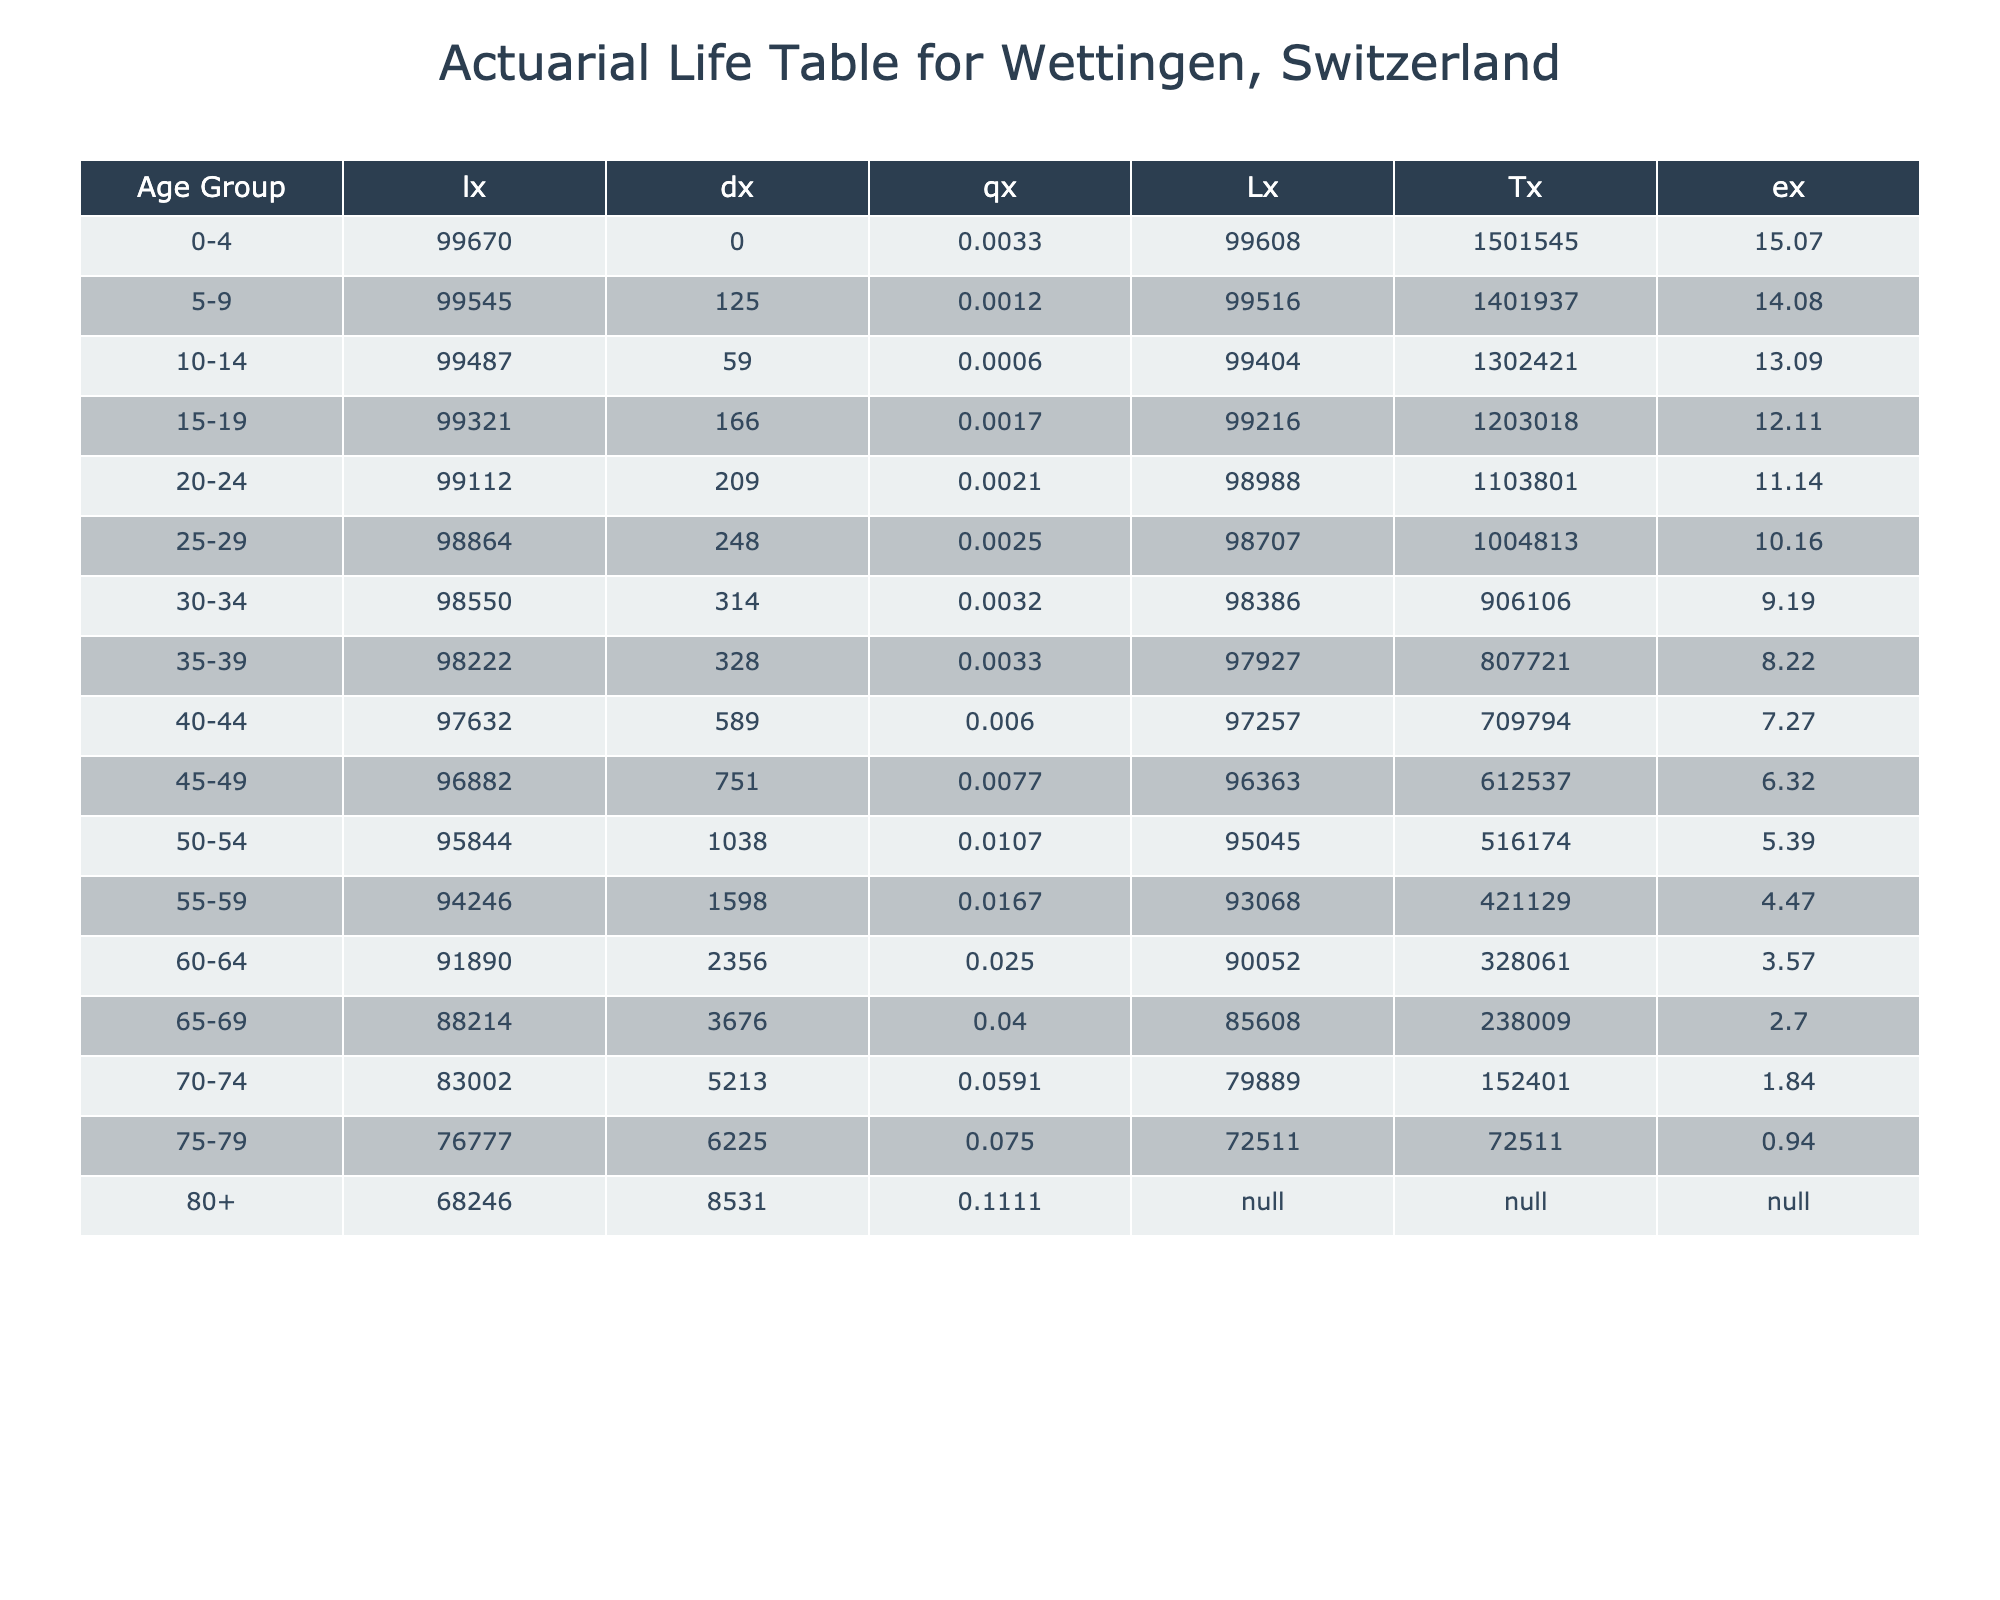What is the mortality rate for the age group 70-74? Looking at the table, we can find the row corresponding to the age group 70-74. The mortality rate in that row is listed as 0.05909.
Answer: 0.05909 How many deaths occurred in the age group 60-64? In the table, for the age group 60-64, the number of deaths is directly stated as 70.
Answer: 70 What is the total number of deaths for age groups 75-79 and 80+? To find the total deaths in those age groups, we look at the respective rows. For 75-79, there are 150 deaths and for 80+, there are 200 deaths. Summing these gives 150 + 200 = 350.
Answer: 350 Is the mortality rate for the age group 50-54 higher than that for 40-44? The mortality rate for 50-54 is 0.01071, while for 40-44 it is 0.006. Since 0.01071 is greater than 0.006, the statement is true.
Answer: Yes What is the average mortality rate for the age groups 15-19, 20-24, and 25-29? First, we find the mortality rates for these age groups: 15-19 is 0.00167, 20-24 is 0.0021, and 25-29 is 0.0025. Adding these gives 0.00167 + 0.0021 + 0.0025 = 0.00627. Now, dividing by 3 (since there are 3 groups) gives an average of 0.00627 / 3 = 0.00209.
Answer: 0.00209 How does the mortality rate change from the age group 45-49 to 55-59? The mortality rate for 45-49 is 0.00769 and for 55-59 it is 0.01667. To find the change, we subtract the first from the second: 0.01667 - 0.00769 = 0.00898. This indicates an increase in mortality rate by 0.00898.
Answer: Increased by 0.00898 